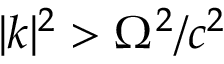Convert formula to latex. <formula><loc_0><loc_0><loc_500><loc_500>| { k } | ^ { 2 } > \Omega ^ { 2 } / c ^ { 2 }</formula> 